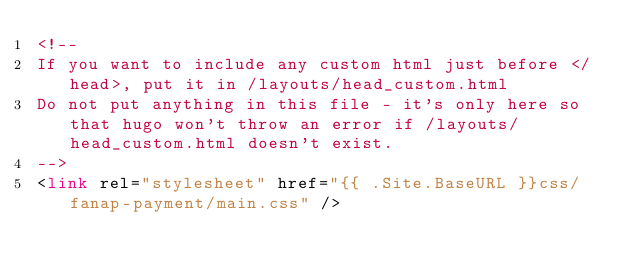Convert code to text. <code><loc_0><loc_0><loc_500><loc_500><_HTML_><!--
If you want to include any custom html just before </head>, put it in /layouts/head_custom.html
Do not put anything in this file - it's only here so that hugo won't throw an error if /layouts/head_custom.html doesn't exist.
-->
<link rel="stylesheet" href="{{ .Site.BaseURL }}css/fanap-payment/main.css" />
</code> 